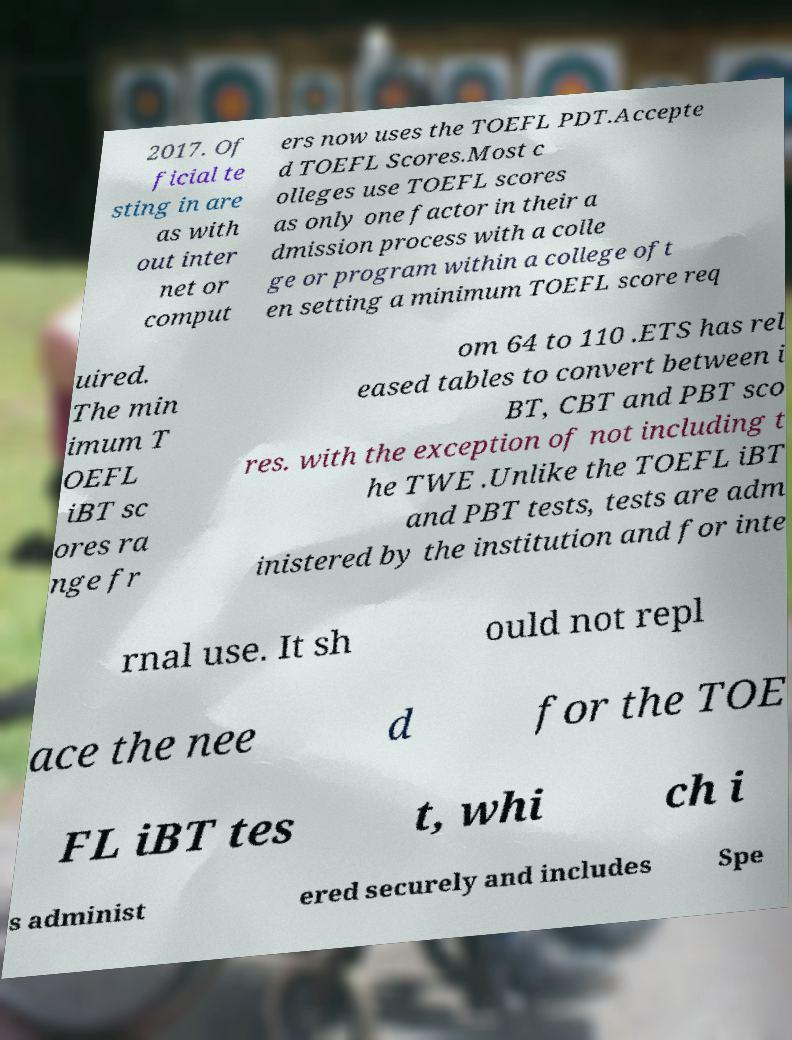What messages or text are displayed in this image? I need them in a readable, typed format. 2017. Of ficial te sting in are as with out inter net or comput ers now uses the TOEFL PDT.Accepte d TOEFL Scores.Most c olleges use TOEFL scores as only one factor in their a dmission process with a colle ge or program within a college oft en setting a minimum TOEFL score req uired. The min imum T OEFL iBT sc ores ra nge fr om 64 to 110 .ETS has rel eased tables to convert between i BT, CBT and PBT sco res. with the exception of not including t he TWE .Unlike the TOEFL iBT and PBT tests, tests are adm inistered by the institution and for inte rnal use. It sh ould not repl ace the nee d for the TOE FL iBT tes t, whi ch i s administ ered securely and includes Spe 